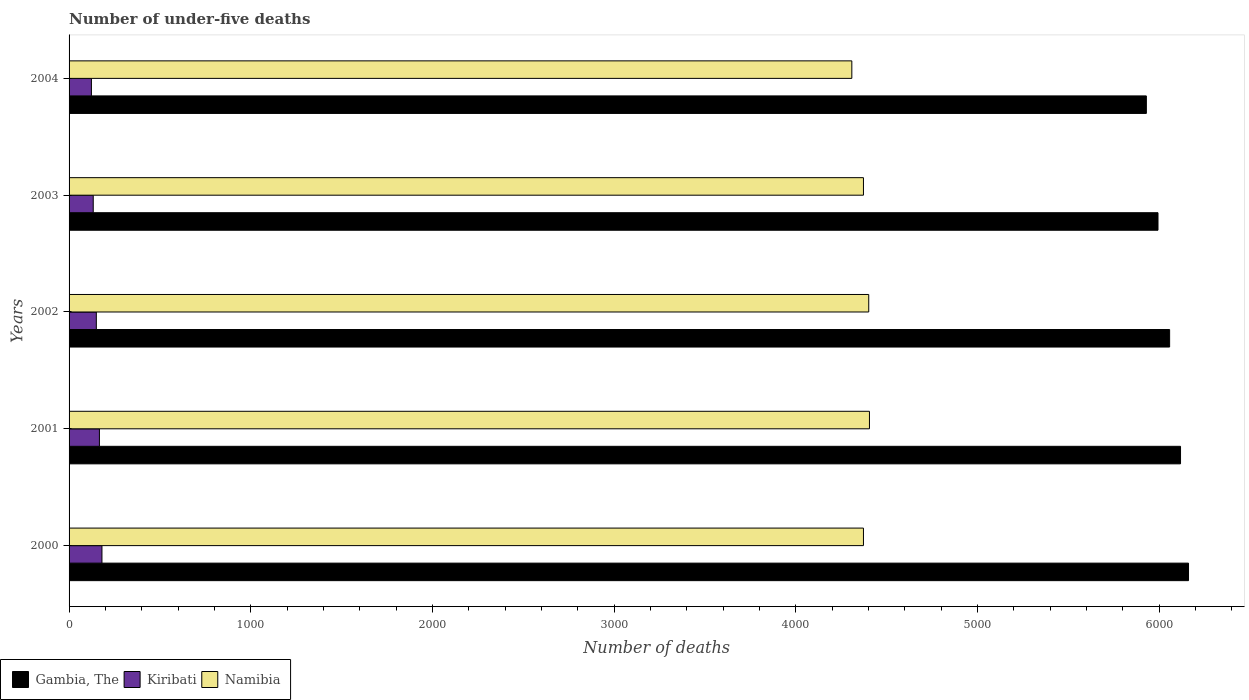How many groups of bars are there?
Your answer should be very brief. 5. Are the number of bars per tick equal to the number of legend labels?
Offer a very short reply. Yes. How many bars are there on the 3rd tick from the top?
Keep it short and to the point. 3. How many bars are there on the 5th tick from the bottom?
Your response must be concise. 3. What is the number of under-five deaths in Namibia in 2001?
Provide a succinct answer. 4405. Across all years, what is the maximum number of under-five deaths in Gambia, The?
Your response must be concise. 6161. Across all years, what is the minimum number of under-five deaths in Gambia, The?
Provide a succinct answer. 5929. In which year was the number of under-five deaths in Namibia maximum?
Offer a very short reply. 2001. What is the total number of under-five deaths in Kiribati in the graph?
Your answer should be very brief. 754. What is the difference between the number of under-five deaths in Gambia, The in 2002 and that in 2003?
Give a very brief answer. 64. What is the difference between the number of under-five deaths in Namibia in 2000 and the number of under-five deaths in Gambia, The in 2001?
Provide a succinct answer. -1745. What is the average number of under-five deaths in Gambia, The per year?
Your answer should be very brief. 6051.4. In the year 2004, what is the difference between the number of under-five deaths in Namibia and number of under-five deaths in Gambia, The?
Make the answer very short. -1621. What is the ratio of the number of under-five deaths in Namibia in 2002 to that in 2004?
Your answer should be very brief. 1.02. Is the number of under-five deaths in Kiribati in 2003 less than that in 2004?
Offer a very short reply. No. Is the difference between the number of under-five deaths in Namibia in 2001 and 2002 greater than the difference between the number of under-five deaths in Gambia, The in 2001 and 2002?
Your answer should be very brief. No. What is the difference between the highest and the lowest number of under-five deaths in Namibia?
Provide a short and direct response. 97. In how many years, is the number of under-five deaths in Kiribati greater than the average number of under-five deaths in Kiribati taken over all years?
Provide a succinct answer. 2. What does the 1st bar from the top in 2002 represents?
Your response must be concise. Namibia. What does the 1st bar from the bottom in 2003 represents?
Provide a short and direct response. Gambia, The. Is it the case that in every year, the sum of the number of under-five deaths in Kiribati and number of under-five deaths in Gambia, The is greater than the number of under-five deaths in Namibia?
Your answer should be very brief. Yes. How many bars are there?
Ensure brevity in your answer.  15. Are all the bars in the graph horizontal?
Your response must be concise. Yes. How many years are there in the graph?
Keep it short and to the point. 5. What is the difference between two consecutive major ticks on the X-axis?
Give a very brief answer. 1000. Does the graph contain grids?
Provide a succinct answer. No. How are the legend labels stacked?
Provide a short and direct response. Horizontal. What is the title of the graph?
Give a very brief answer. Number of under-five deaths. Does "Lithuania" appear as one of the legend labels in the graph?
Offer a terse response. No. What is the label or title of the X-axis?
Offer a very short reply. Number of deaths. What is the Number of deaths of Gambia, The in 2000?
Offer a very short reply. 6161. What is the Number of deaths in Kiribati in 2000?
Offer a very short reply. 181. What is the Number of deaths in Namibia in 2000?
Keep it short and to the point. 4372. What is the Number of deaths in Gambia, The in 2001?
Offer a very short reply. 6117. What is the Number of deaths of Kiribati in 2001?
Your answer should be very brief. 167. What is the Number of deaths in Namibia in 2001?
Offer a very short reply. 4405. What is the Number of deaths of Gambia, The in 2002?
Make the answer very short. 6057. What is the Number of deaths of Kiribati in 2002?
Your answer should be compact. 150. What is the Number of deaths of Namibia in 2002?
Offer a terse response. 4401. What is the Number of deaths of Gambia, The in 2003?
Offer a terse response. 5993. What is the Number of deaths of Kiribati in 2003?
Your answer should be very brief. 133. What is the Number of deaths in Namibia in 2003?
Give a very brief answer. 4372. What is the Number of deaths of Gambia, The in 2004?
Keep it short and to the point. 5929. What is the Number of deaths of Kiribati in 2004?
Give a very brief answer. 123. What is the Number of deaths of Namibia in 2004?
Provide a short and direct response. 4308. Across all years, what is the maximum Number of deaths of Gambia, The?
Provide a short and direct response. 6161. Across all years, what is the maximum Number of deaths in Kiribati?
Offer a terse response. 181. Across all years, what is the maximum Number of deaths in Namibia?
Provide a succinct answer. 4405. Across all years, what is the minimum Number of deaths in Gambia, The?
Offer a terse response. 5929. Across all years, what is the minimum Number of deaths of Kiribati?
Provide a short and direct response. 123. Across all years, what is the minimum Number of deaths of Namibia?
Give a very brief answer. 4308. What is the total Number of deaths of Gambia, The in the graph?
Offer a terse response. 3.03e+04. What is the total Number of deaths in Kiribati in the graph?
Provide a succinct answer. 754. What is the total Number of deaths in Namibia in the graph?
Offer a very short reply. 2.19e+04. What is the difference between the Number of deaths in Gambia, The in 2000 and that in 2001?
Offer a terse response. 44. What is the difference between the Number of deaths in Kiribati in 2000 and that in 2001?
Provide a succinct answer. 14. What is the difference between the Number of deaths in Namibia in 2000 and that in 2001?
Ensure brevity in your answer.  -33. What is the difference between the Number of deaths in Gambia, The in 2000 and that in 2002?
Provide a succinct answer. 104. What is the difference between the Number of deaths of Namibia in 2000 and that in 2002?
Make the answer very short. -29. What is the difference between the Number of deaths in Gambia, The in 2000 and that in 2003?
Your answer should be compact. 168. What is the difference between the Number of deaths in Kiribati in 2000 and that in 2003?
Give a very brief answer. 48. What is the difference between the Number of deaths of Namibia in 2000 and that in 2003?
Your answer should be very brief. 0. What is the difference between the Number of deaths of Gambia, The in 2000 and that in 2004?
Give a very brief answer. 232. What is the difference between the Number of deaths of Kiribati in 2000 and that in 2004?
Offer a terse response. 58. What is the difference between the Number of deaths in Gambia, The in 2001 and that in 2002?
Keep it short and to the point. 60. What is the difference between the Number of deaths of Gambia, The in 2001 and that in 2003?
Your response must be concise. 124. What is the difference between the Number of deaths in Kiribati in 2001 and that in 2003?
Make the answer very short. 34. What is the difference between the Number of deaths in Gambia, The in 2001 and that in 2004?
Your response must be concise. 188. What is the difference between the Number of deaths in Kiribati in 2001 and that in 2004?
Offer a very short reply. 44. What is the difference between the Number of deaths of Namibia in 2001 and that in 2004?
Your answer should be compact. 97. What is the difference between the Number of deaths of Namibia in 2002 and that in 2003?
Provide a short and direct response. 29. What is the difference between the Number of deaths of Gambia, The in 2002 and that in 2004?
Your answer should be compact. 128. What is the difference between the Number of deaths of Namibia in 2002 and that in 2004?
Make the answer very short. 93. What is the difference between the Number of deaths of Gambia, The in 2003 and that in 2004?
Keep it short and to the point. 64. What is the difference between the Number of deaths of Kiribati in 2003 and that in 2004?
Ensure brevity in your answer.  10. What is the difference between the Number of deaths in Gambia, The in 2000 and the Number of deaths in Kiribati in 2001?
Give a very brief answer. 5994. What is the difference between the Number of deaths in Gambia, The in 2000 and the Number of deaths in Namibia in 2001?
Provide a succinct answer. 1756. What is the difference between the Number of deaths of Kiribati in 2000 and the Number of deaths of Namibia in 2001?
Make the answer very short. -4224. What is the difference between the Number of deaths of Gambia, The in 2000 and the Number of deaths of Kiribati in 2002?
Your response must be concise. 6011. What is the difference between the Number of deaths of Gambia, The in 2000 and the Number of deaths of Namibia in 2002?
Offer a terse response. 1760. What is the difference between the Number of deaths in Kiribati in 2000 and the Number of deaths in Namibia in 2002?
Ensure brevity in your answer.  -4220. What is the difference between the Number of deaths of Gambia, The in 2000 and the Number of deaths of Kiribati in 2003?
Your answer should be very brief. 6028. What is the difference between the Number of deaths in Gambia, The in 2000 and the Number of deaths in Namibia in 2003?
Give a very brief answer. 1789. What is the difference between the Number of deaths in Kiribati in 2000 and the Number of deaths in Namibia in 2003?
Give a very brief answer. -4191. What is the difference between the Number of deaths in Gambia, The in 2000 and the Number of deaths in Kiribati in 2004?
Offer a very short reply. 6038. What is the difference between the Number of deaths in Gambia, The in 2000 and the Number of deaths in Namibia in 2004?
Your response must be concise. 1853. What is the difference between the Number of deaths of Kiribati in 2000 and the Number of deaths of Namibia in 2004?
Make the answer very short. -4127. What is the difference between the Number of deaths of Gambia, The in 2001 and the Number of deaths of Kiribati in 2002?
Provide a short and direct response. 5967. What is the difference between the Number of deaths in Gambia, The in 2001 and the Number of deaths in Namibia in 2002?
Offer a very short reply. 1716. What is the difference between the Number of deaths of Kiribati in 2001 and the Number of deaths of Namibia in 2002?
Your answer should be very brief. -4234. What is the difference between the Number of deaths in Gambia, The in 2001 and the Number of deaths in Kiribati in 2003?
Offer a very short reply. 5984. What is the difference between the Number of deaths of Gambia, The in 2001 and the Number of deaths of Namibia in 2003?
Give a very brief answer. 1745. What is the difference between the Number of deaths in Kiribati in 2001 and the Number of deaths in Namibia in 2003?
Offer a very short reply. -4205. What is the difference between the Number of deaths in Gambia, The in 2001 and the Number of deaths in Kiribati in 2004?
Your response must be concise. 5994. What is the difference between the Number of deaths in Gambia, The in 2001 and the Number of deaths in Namibia in 2004?
Ensure brevity in your answer.  1809. What is the difference between the Number of deaths of Kiribati in 2001 and the Number of deaths of Namibia in 2004?
Your answer should be compact. -4141. What is the difference between the Number of deaths of Gambia, The in 2002 and the Number of deaths of Kiribati in 2003?
Your response must be concise. 5924. What is the difference between the Number of deaths in Gambia, The in 2002 and the Number of deaths in Namibia in 2003?
Offer a very short reply. 1685. What is the difference between the Number of deaths of Kiribati in 2002 and the Number of deaths of Namibia in 2003?
Provide a succinct answer. -4222. What is the difference between the Number of deaths in Gambia, The in 2002 and the Number of deaths in Kiribati in 2004?
Your answer should be very brief. 5934. What is the difference between the Number of deaths of Gambia, The in 2002 and the Number of deaths of Namibia in 2004?
Give a very brief answer. 1749. What is the difference between the Number of deaths in Kiribati in 2002 and the Number of deaths in Namibia in 2004?
Provide a short and direct response. -4158. What is the difference between the Number of deaths in Gambia, The in 2003 and the Number of deaths in Kiribati in 2004?
Offer a terse response. 5870. What is the difference between the Number of deaths in Gambia, The in 2003 and the Number of deaths in Namibia in 2004?
Give a very brief answer. 1685. What is the difference between the Number of deaths of Kiribati in 2003 and the Number of deaths of Namibia in 2004?
Offer a terse response. -4175. What is the average Number of deaths of Gambia, The per year?
Make the answer very short. 6051.4. What is the average Number of deaths of Kiribati per year?
Provide a succinct answer. 150.8. What is the average Number of deaths of Namibia per year?
Make the answer very short. 4371.6. In the year 2000, what is the difference between the Number of deaths in Gambia, The and Number of deaths in Kiribati?
Make the answer very short. 5980. In the year 2000, what is the difference between the Number of deaths of Gambia, The and Number of deaths of Namibia?
Offer a very short reply. 1789. In the year 2000, what is the difference between the Number of deaths of Kiribati and Number of deaths of Namibia?
Offer a very short reply. -4191. In the year 2001, what is the difference between the Number of deaths of Gambia, The and Number of deaths of Kiribati?
Make the answer very short. 5950. In the year 2001, what is the difference between the Number of deaths of Gambia, The and Number of deaths of Namibia?
Make the answer very short. 1712. In the year 2001, what is the difference between the Number of deaths in Kiribati and Number of deaths in Namibia?
Make the answer very short. -4238. In the year 2002, what is the difference between the Number of deaths in Gambia, The and Number of deaths in Kiribati?
Offer a terse response. 5907. In the year 2002, what is the difference between the Number of deaths in Gambia, The and Number of deaths in Namibia?
Provide a succinct answer. 1656. In the year 2002, what is the difference between the Number of deaths of Kiribati and Number of deaths of Namibia?
Offer a very short reply. -4251. In the year 2003, what is the difference between the Number of deaths of Gambia, The and Number of deaths of Kiribati?
Ensure brevity in your answer.  5860. In the year 2003, what is the difference between the Number of deaths in Gambia, The and Number of deaths in Namibia?
Ensure brevity in your answer.  1621. In the year 2003, what is the difference between the Number of deaths of Kiribati and Number of deaths of Namibia?
Keep it short and to the point. -4239. In the year 2004, what is the difference between the Number of deaths in Gambia, The and Number of deaths in Kiribati?
Offer a very short reply. 5806. In the year 2004, what is the difference between the Number of deaths in Gambia, The and Number of deaths in Namibia?
Provide a succinct answer. 1621. In the year 2004, what is the difference between the Number of deaths of Kiribati and Number of deaths of Namibia?
Your answer should be compact. -4185. What is the ratio of the Number of deaths of Kiribati in 2000 to that in 2001?
Make the answer very short. 1.08. What is the ratio of the Number of deaths of Namibia in 2000 to that in 2001?
Give a very brief answer. 0.99. What is the ratio of the Number of deaths of Gambia, The in 2000 to that in 2002?
Offer a very short reply. 1.02. What is the ratio of the Number of deaths of Kiribati in 2000 to that in 2002?
Your answer should be very brief. 1.21. What is the ratio of the Number of deaths in Namibia in 2000 to that in 2002?
Provide a short and direct response. 0.99. What is the ratio of the Number of deaths of Gambia, The in 2000 to that in 2003?
Your answer should be very brief. 1.03. What is the ratio of the Number of deaths of Kiribati in 2000 to that in 2003?
Make the answer very short. 1.36. What is the ratio of the Number of deaths of Namibia in 2000 to that in 2003?
Provide a succinct answer. 1. What is the ratio of the Number of deaths in Gambia, The in 2000 to that in 2004?
Ensure brevity in your answer.  1.04. What is the ratio of the Number of deaths in Kiribati in 2000 to that in 2004?
Your answer should be compact. 1.47. What is the ratio of the Number of deaths of Namibia in 2000 to that in 2004?
Provide a succinct answer. 1.01. What is the ratio of the Number of deaths of Gambia, The in 2001 to that in 2002?
Provide a succinct answer. 1.01. What is the ratio of the Number of deaths of Kiribati in 2001 to that in 2002?
Your answer should be compact. 1.11. What is the ratio of the Number of deaths of Gambia, The in 2001 to that in 2003?
Offer a very short reply. 1.02. What is the ratio of the Number of deaths of Kiribati in 2001 to that in 2003?
Your answer should be compact. 1.26. What is the ratio of the Number of deaths in Namibia in 2001 to that in 2003?
Offer a very short reply. 1.01. What is the ratio of the Number of deaths of Gambia, The in 2001 to that in 2004?
Offer a very short reply. 1.03. What is the ratio of the Number of deaths in Kiribati in 2001 to that in 2004?
Offer a terse response. 1.36. What is the ratio of the Number of deaths in Namibia in 2001 to that in 2004?
Provide a succinct answer. 1.02. What is the ratio of the Number of deaths in Gambia, The in 2002 to that in 2003?
Your response must be concise. 1.01. What is the ratio of the Number of deaths of Kiribati in 2002 to that in 2003?
Make the answer very short. 1.13. What is the ratio of the Number of deaths of Namibia in 2002 to that in 2003?
Provide a short and direct response. 1.01. What is the ratio of the Number of deaths of Gambia, The in 2002 to that in 2004?
Provide a short and direct response. 1.02. What is the ratio of the Number of deaths of Kiribati in 2002 to that in 2004?
Your answer should be compact. 1.22. What is the ratio of the Number of deaths of Namibia in 2002 to that in 2004?
Your answer should be very brief. 1.02. What is the ratio of the Number of deaths of Gambia, The in 2003 to that in 2004?
Keep it short and to the point. 1.01. What is the ratio of the Number of deaths of Kiribati in 2003 to that in 2004?
Your answer should be compact. 1.08. What is the ratio of the Number of deaths in Namibia in 2003 to that in 2004?
Offer a very short reply. 1.01. What is the difference between the highest and the lowest Number of deaths of Gambia, The?
Give a very brief answer. 232. What is the difference between the highest and the lowest Number of deaths in Namibia?
Give a very brief answer. 97. 